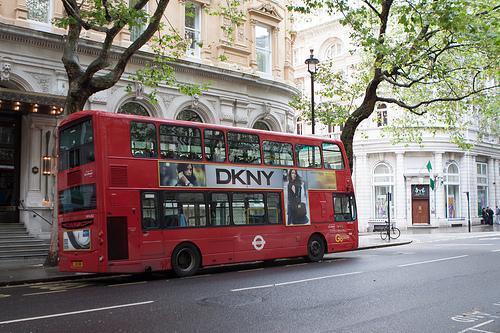How many buses are in the picture?
Give a very brief answer. 1. How many buildings are in the picture?
Give a very brief answer. 2. 